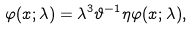<formula> <loc_0><loc_0><loc_500><loc_500>\varphi ( x ; \lambda ) = \lambda ^ { 3 } \vartheta ^ { - 1 } \eta \varphi ( x ; \lambda ) ,</formula> 